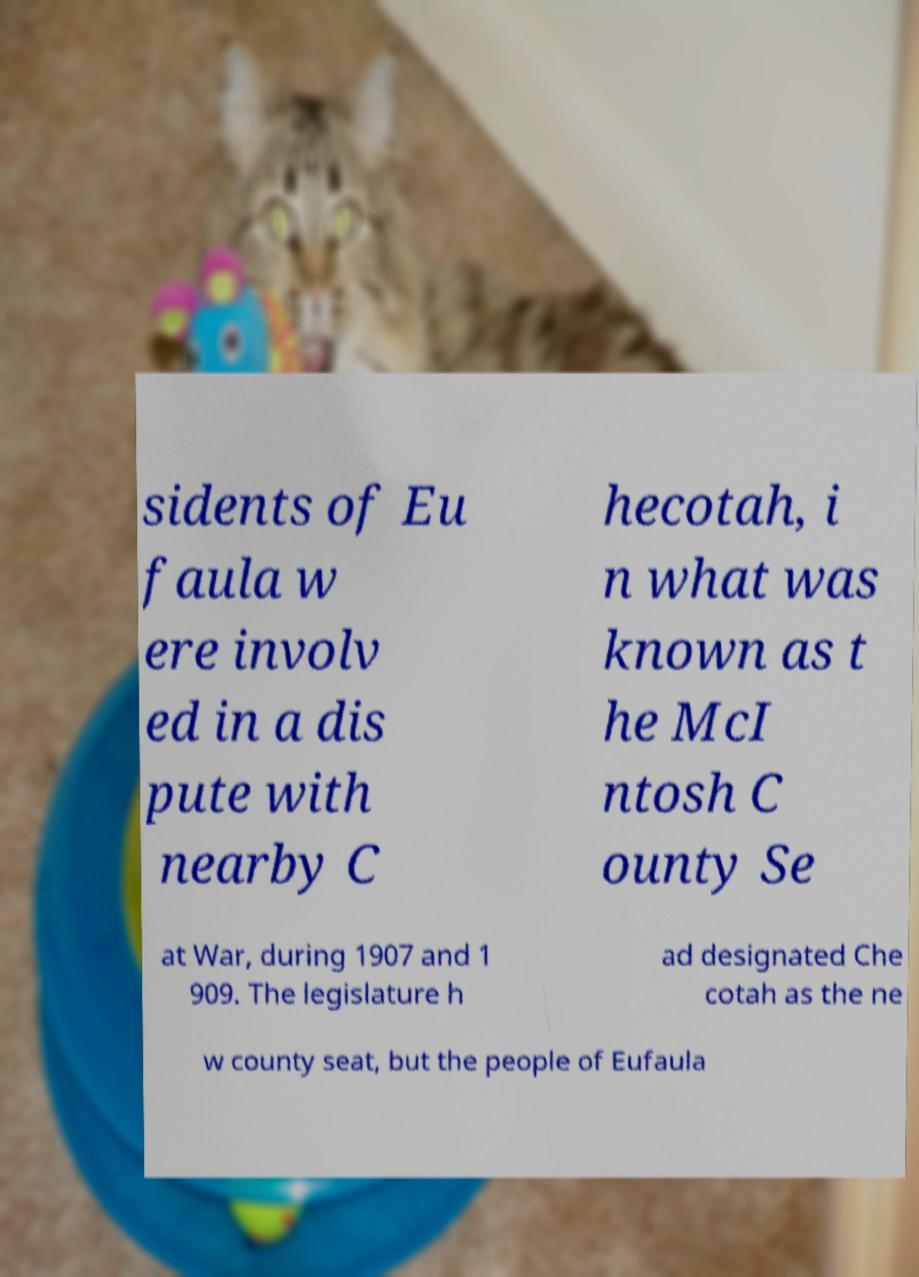Can you read and provide the text displayed in the image?This photo seems to have some interesting text. Can you extract and type it out for me? sidents of Eu faula w ere involv ed in a dis pute with nearby C hecotah, i n what was known as t he McI ntosh C ounty Se at War, during 1907 and 1 909. The legislature h ad designated Che cotah as the ne w county seat, but the people of Eufaula 